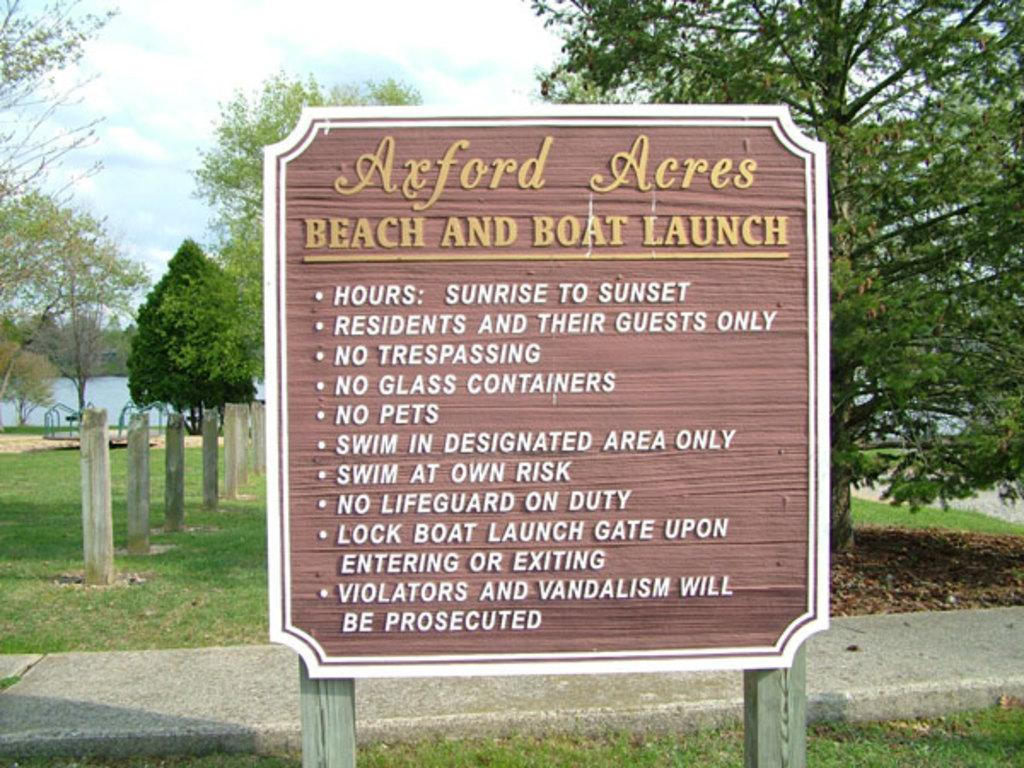What is the main object in the image? There is a board in the image. What can be seen behind the board? There are poles behind the board. What type of terrain is visible in the image? Grassy land is visible in the image. What other natural elements are present in the image? Trees are present in the image. What is the condition of the sky in the image? The sky is covered with clouds. What is the tendency of the ladybugs to gather on the board in the image? There are no ladybugs present in the image, so it is not possible to determine their tendency to gather on the board. 